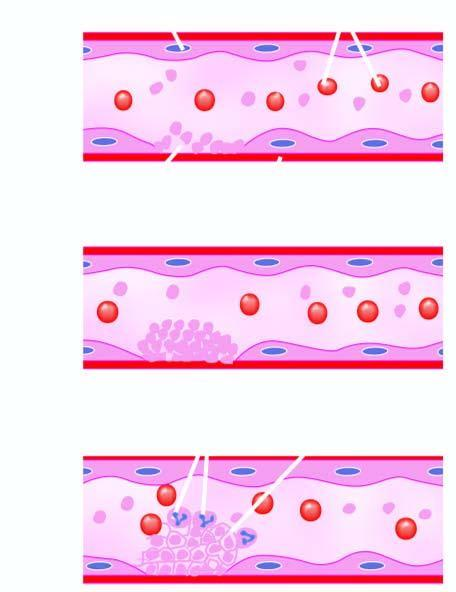s some leucocytes and red cells and a tight meshwork formed called thrombus?
Answer the question using a single word or phrase. Yes 